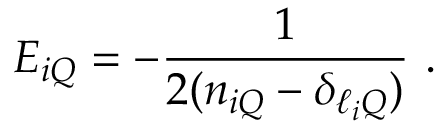<formula> <loc_0><loc_0><loc_500><loc_500>E _ { i Q } = - \frac { 1 } { 2 ( n _ { i Q } - \delta _ { \ell _ { i } Q } ) } \, .</formula> 